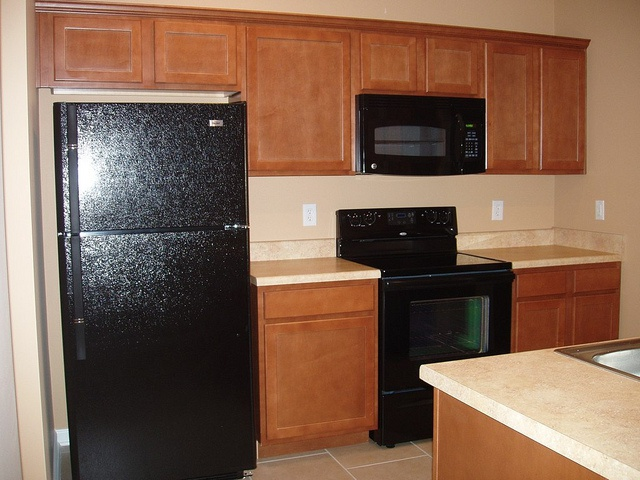Describe the objects in this image and their specific colors. I can see refrigerator in tan, black, gray, darkgray, and lightgray tones, oven in tan, black, gray, maroon, and darkgreen tones, microwave in tan, black, gray, and maroon tones, and sink in tan, maroon, darkgray, and lightgray tones in this image. 